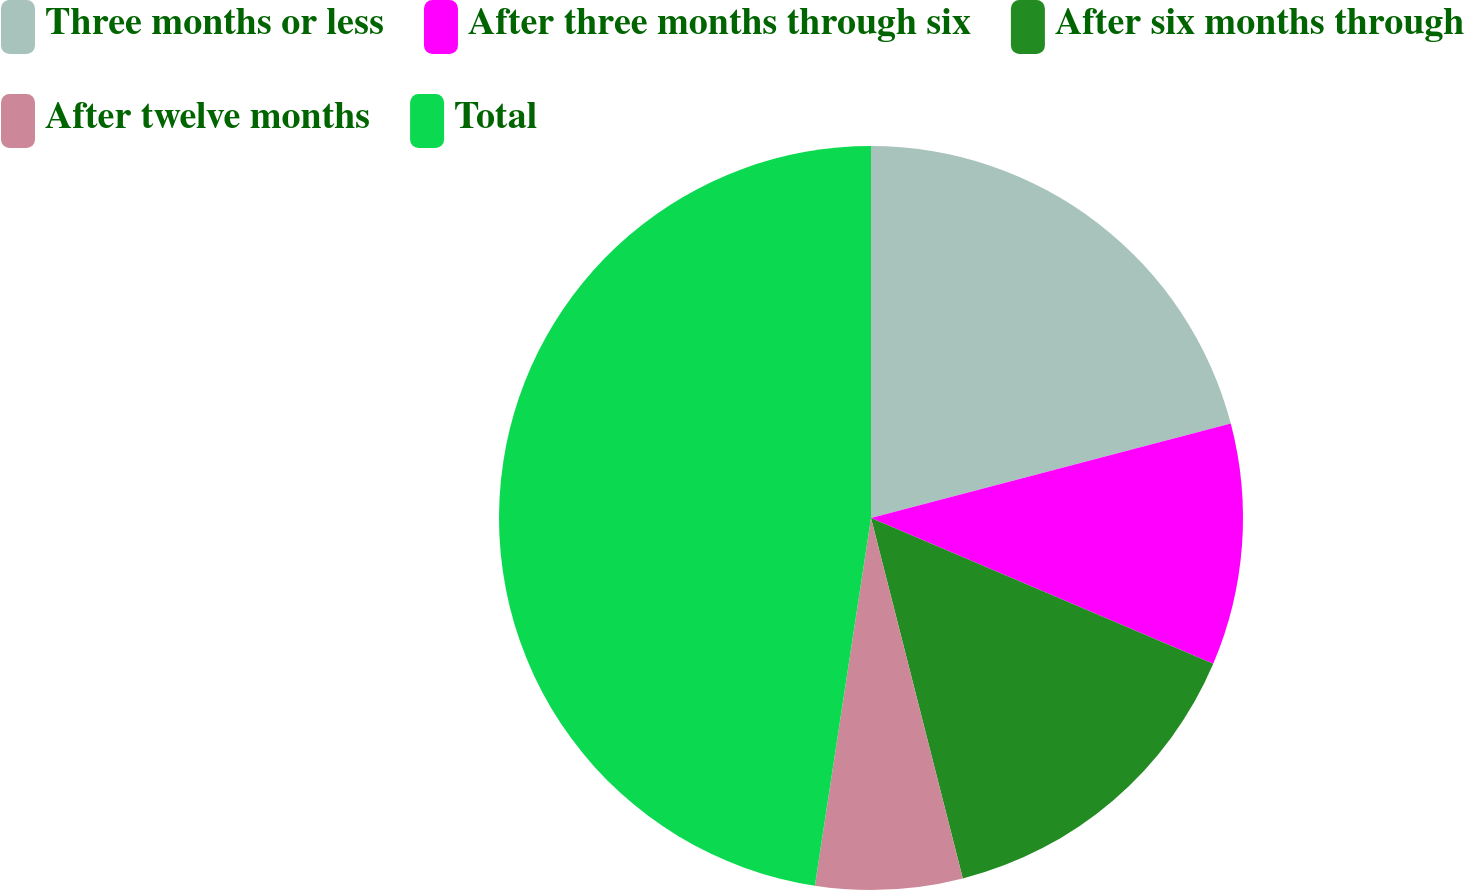<chart> <loc_0><loc_0><loc_500><loc_500><pie_chart><fcel>Three months or less<fcel>After three months through six<fcel>After six months through<fcel>After twelve months<fcel>Total<nl><fcel>20.91%<fcel>10.5%<fcel>14.62%<fcel>6.38%<fcel>47.59%<nl></chart> 